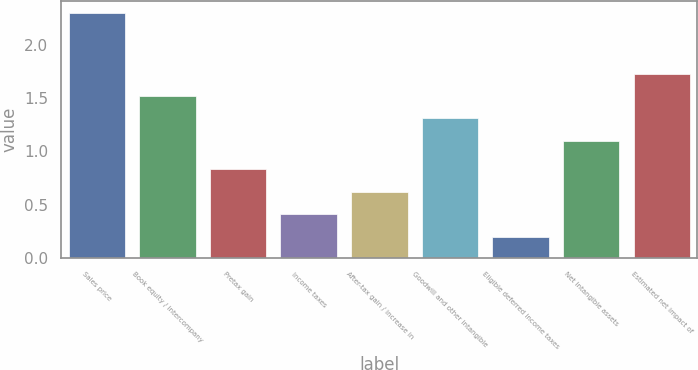Convert chart. <chart><loc_0><loc_0><loc_500><loc_500><bar_chart><fcel>Sales price<fcel>Book equity / intercompany<fcel>Pretax gain<fcel>Income taxes<fcel>After-tax gain / increase in<fcel>Goodwill and other intangible<fcel>Eligible deferred income taxes<fcel>Net intangible assets<fcel>Estimated net impact of<nl><fcel>2.3<fcel>1.52<fcel>0.83<fcel>0.41<fcel>0.62<fcel>1.31<fcel>0.2<fcel>1.1<fcel>1.73<nl></chart> 